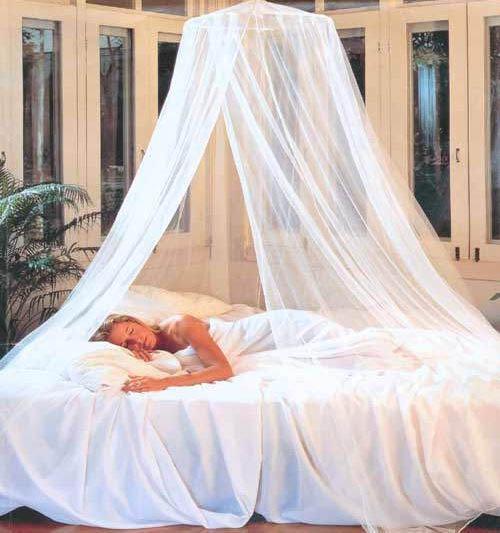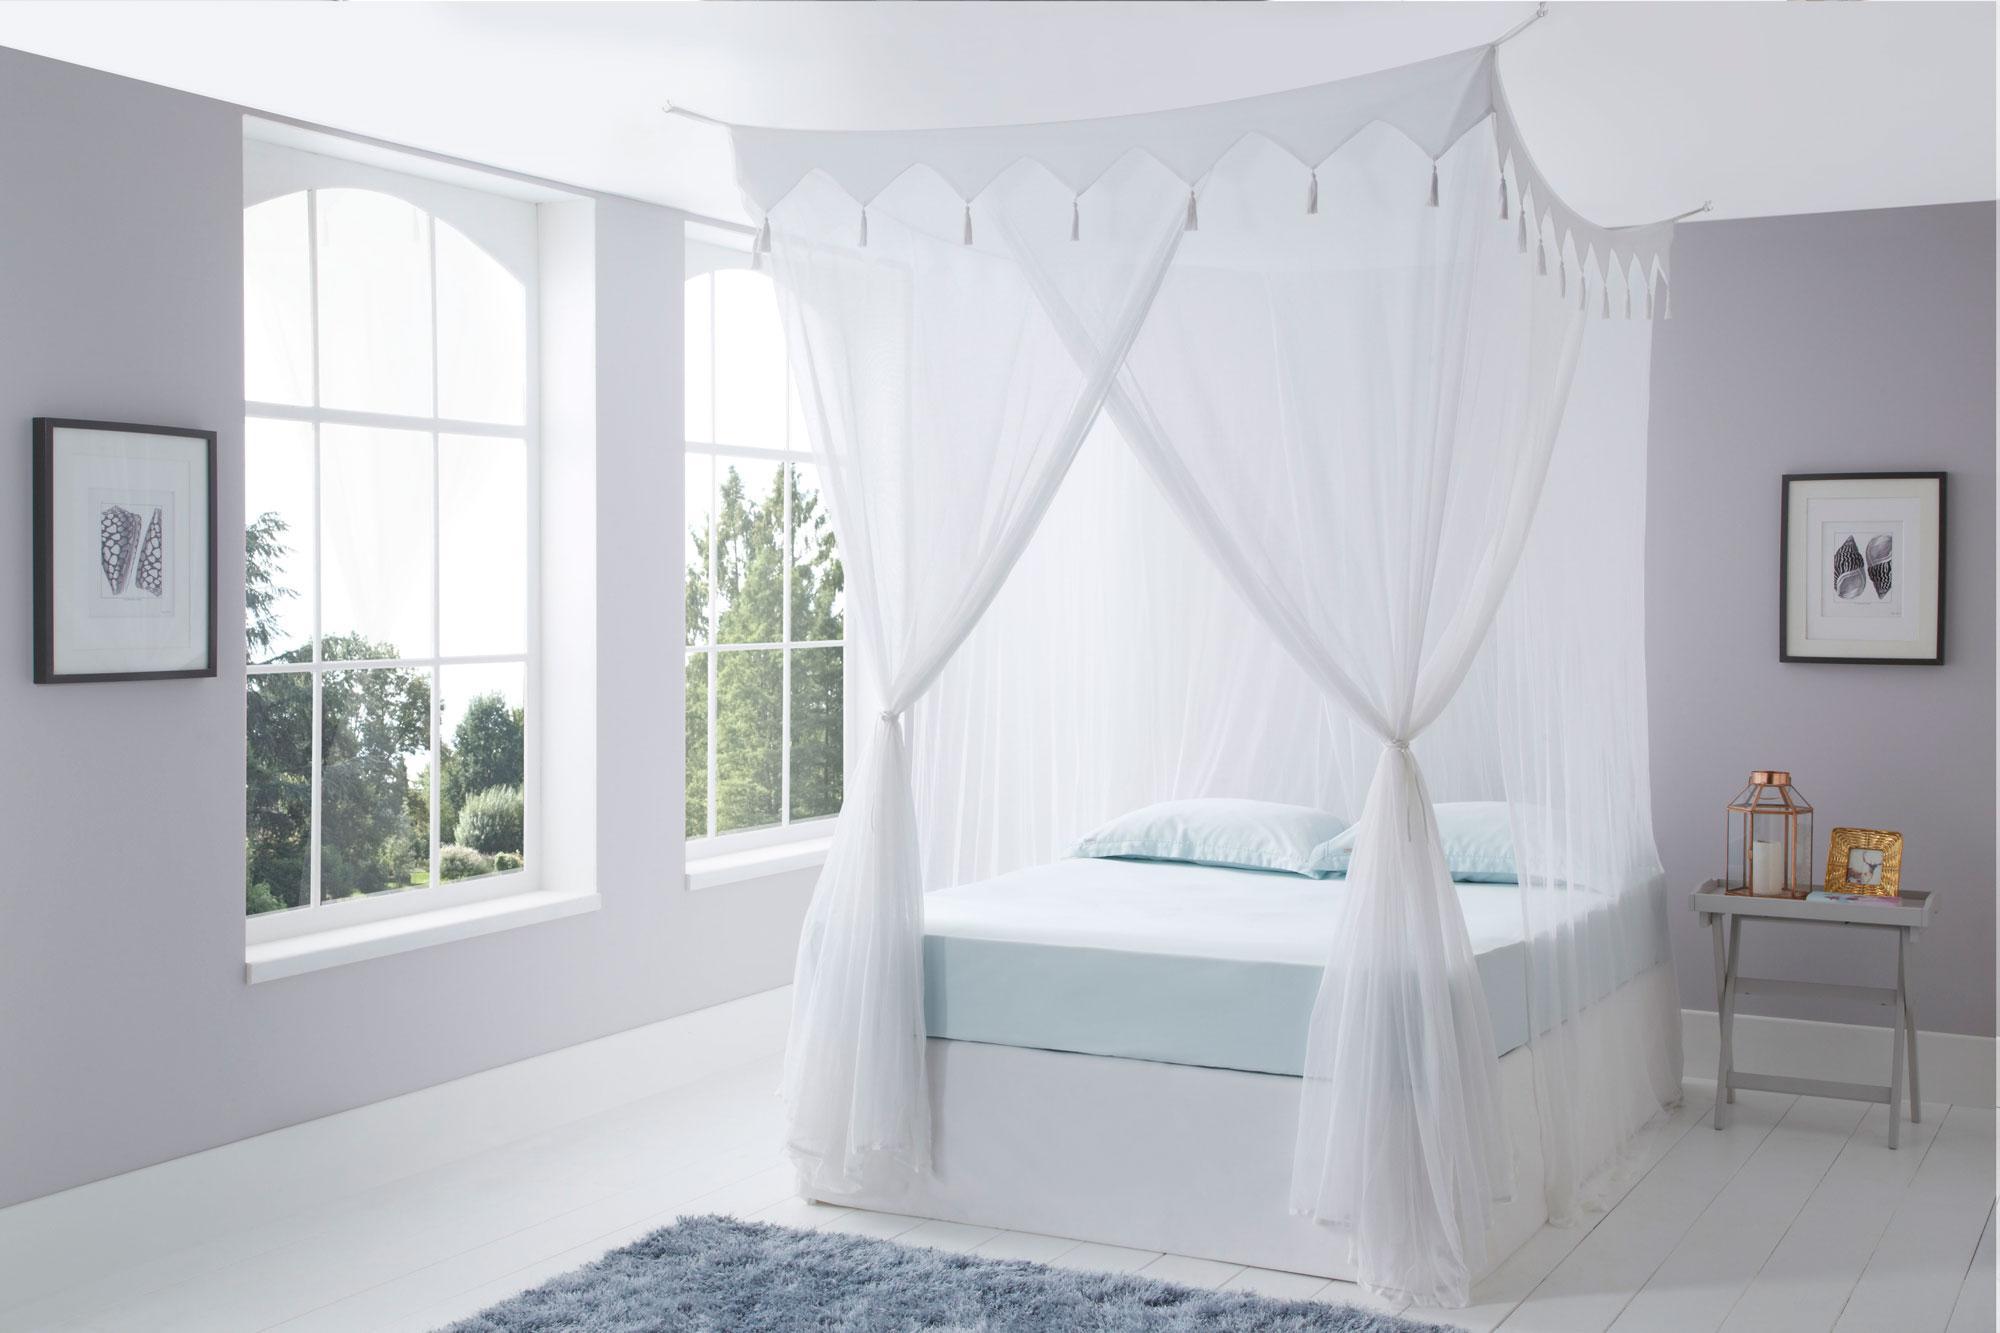The first image is the image on the left, the second image is the image on the right. Analyze the images presented: Is the assertion "One image shows a ceiling-suspended gauzy white canopy that hangs over the middle of a bed in a cone shape that extends around most of the bed." valid? Answer yes or no. Yes. The first image is the image on the left, the second image is the image on the right. For the images shown, is this caption "In at least one image there is a squared canopy with two of the lace curtains tied to the end of the bed poles." true? Answer yes or no. Yes. 